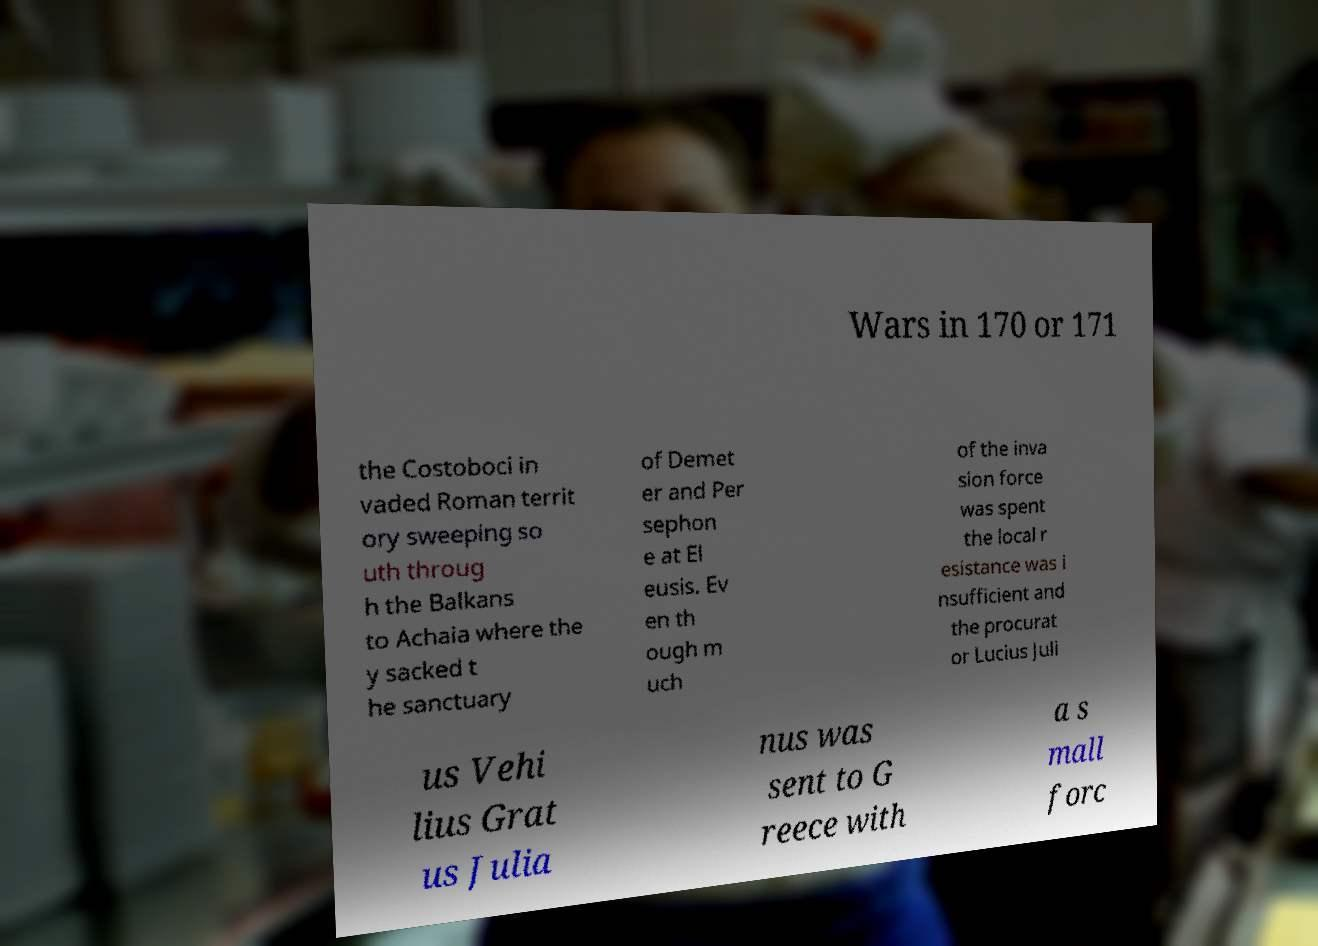Can you read and provide the text displayed in the image?This photo seems to have some interesting text. Can you extract and type it out for me? Wars in 170 or 171 the Costoboci in vaded Roman territ ory sweeping so uth throug h the Balkans to Achaia where the y sacked t he sanctuary of Demet er and Per sephon e at El eusis. Ev en th ough m uch of the inva sion force was spent the local r esistance was i nsufficient and the procurat or Lucius Juli us Vehi lius Grat us Julia nus was sent to G reece with a s mall forc 